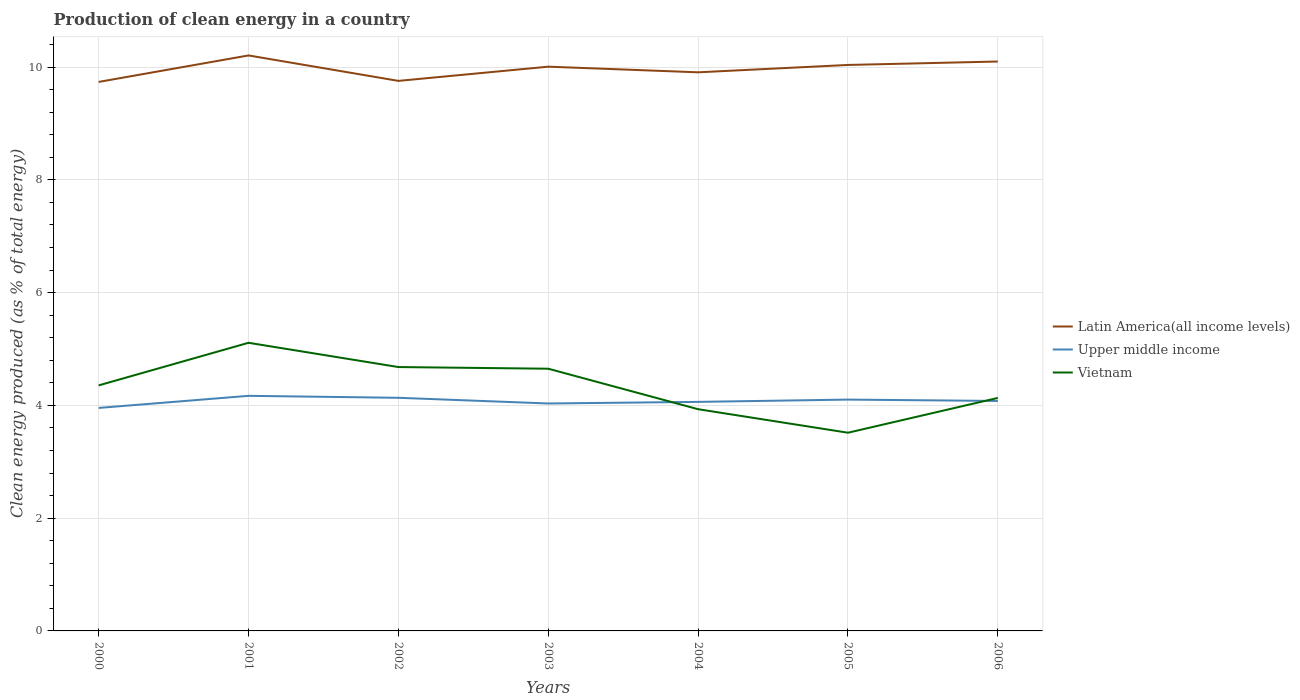How many different coloured lines are there?
Your answer should be very brief. 3. Is the number of lines equal to the number of legend labels?
Provide a short and direct response. Yes. Across all years, what is the maximum percentage of clean energy produced in Upper middle income?
Your answer should be very brief. 3.95. In which year was the percentage of clean energy produced in Upper middle income maximum?
Offer a terse response. 2000. What is the total percentage of clean energy produced in Latin America(all income levels) in the graph?
Your answer should be very brief. 0.11. What is the difference between the highest and the second highest percentage of clean energy produced in Latin America(all income levels)?
Make the answer very short. 0.47. What is the difference between the highest and the lowest percentage of clean energy produced in Upper middle income?
Offer a very short reply. 4. Is the percentage of clean energy produced in Vietnam strictly greater than the percentage of clean energy produced in Latin America(all income levels) over the years?
Your response must be concise. Yes. How many lines are there?
Provide a short and direct response. 3. What is the difference between two consecutive major ticks on the Y-axis?
Provide a short and direct response. 2. Are the values on the major ticks of Y-axis written in scientific E-notation?
Your response must be concise. No. Does the graph contain any zero values?
Provide a short and direct response. No. Does the graph contain grids?
Provide a succinct answer. Yes. Where does the legend appear in the graph?
Your answer should be very brief. Center right. How many legend labels are there?
Make the answer very short. 3. What is the title of the graph?
Ensure brevity in your answer.  Production of clean energy in a country. What is the label or title of the Y-axis?
Provide a short and direct response. Clean energy produced (as % of total energy). What is the Clean energy produced (as % of total energy) in Latin America(all income levels) in 2000?
Your response must be concise. 9.74. What is the Clean energy produced (as % of total energy) of Upper middle income in 2000?
Give a very brief answer. 3.95. What is the Clean energy produced (as % of total energy) of Vietnam in 2000?
Provide a succinct answer. 4.35. What is the Clean energy produced (as % of total energy) of Latin America(all income levels) in 2001?
Your response must be concise. 10.21. What is the Clean energy produced (as % of total energy) in Upper middle income in 2001?
Provide a succinct answer. 4.17. What is the Clean energy produced (as % of total energy) of Vietnam in 2001?
Give a very brief answer. 5.11. What is the Clean energy produced (as % of total energy) in Latin America(all income levels) in 2002?
Your answer should be very brief. 9.76. What is the Clean energy produced (as % of total energy) in Upper middle income in 2002?
Your response must be concise. 4.13. What is the Clean energy produced (as % of total energy) in Vietnam in 2002?
Ensure brevity in your answer.  4.68. What is the Clean energy produced (as % of total energy) of Latin America(all income levels) in 2003?
Keep it short and to the point. 10.01. What is the Clean energy produced (as % of total energy) in Upper middle income in 2003?
Your answer should be very brief. 4.03. What is the Clean energy produced (as % of total energy) in Vietnam in 2003?
Your response must be concise. 4.65. What is the Clean energy produced (as % of total energy) in Latin America(all income levels) in 2004?
Give a very brief answer. 9.91. What is the Clean energy produced (as % of total energy) of Upper middle income in 2004?
Offer a very short reply. 4.06. What is the Clean energy produced (as % of total energy) of Vietnam in 2004?
Ensure brevity in your answer.  3.93. What is the Clean energy produced (as % of total energy) in Latin America(all income levels) in 2005?
Your answer should be very brief. 10.04. What is the Clean energy produced (as % of total energy) in Upper middle income in 2005?
Keep it short and to the point. 4.1. What is the Clean energy produced (as % of total energy) of Vietnam in 2005?
Offer a terse response. 3.52. What is the Clean energy produced (as % of total energy) in Latin America(all income levels) in 2006?
Give a very brief answer. 10.1. What is the Clean energy produced (as % of total energy) of Upper middle income in 2006?
Keep it short and to the point. 4.08. What is the Clean energy produced (as % of total energy) of Vietnam in 2006?
Provide a succinct answer. 4.13. Across all years, what is the maximum Clean energy produced (as % of total energy) in Latin America(all income levels)?
Your answer should be very brief. 10.21. Across all years, what is the maximum Clean energy produced (as % of total energy) in Upper middle income?
Give a very brief answer. 4.17. Across all years, what is the maximum Clean energy produced (as % of total energy) of Vietnam?
Offer a very short reply. 5.11. Across all years, what is the minimum Clean energy produced (as % of total energy) in Latin America(all income levels)?
Ensure brevity in your answer.  9.74. Across all years, what is the minimum Clean energy produced (as % of total energy) of Upper middle income?
Your response must be concise. 3.95. Across all years, what is the minimum Clean energy produced (as % of total energy) of Vietnam?
Give a very brief answer. 3.52. What is the total Clean energy produced (as % of total energy) of Latin America(all income levels) in the graph?
Provide a short and direct response. 69.75. What is the total Clean energy produced (as % of total energy) in Upper middle income in the graph?
Keep it short and to the point. 28.54. What is the total Clean energy produced (as % of total energy) of Vietnam in the graph?
Give a very brief answer. 30.38. What is the difference between the Clean energy produced (as % of total energy) of Latin America(all income levels) in 2000 and that in 2001?
Ensure brevity in your answer.  -0.47. What is the difference between the Clean energy produced (as % of total energy) in Upper middle income in 2000 and that in 2001?
Your answer should be compact. -0.21. What is the difference between the Clean energy produced (as % of total energy) of Vietnam in 2000 and that in 2001?
Ensure brevity in your answer.  -0.76. What is the difference between the Clean energy produced (as % of total energy) of Latin America(all income levels) in 2000 and that in 2002?
Your answer should be very brief. -0.02. What is the difference between the Clean energy produced (as % of total energy) of Upper middle income in 2000 and that in 2002?
Make the answer very short. -0.18. What is the difference between the Clean energy produced (as % of total energy) in Vietnam in 2000 and that in 2002?
Keep it short and to the point. -0.33. What is the difference between the Clean energy produced (as % of total energy) of Latin America(all income levels) in 2000 and that in 2003?
Keep it short and to the point. -0.27. What is the difference between the Clean energy produced (as % of total energy) in Upper middle income in 2000 and that in 2003?
Provide a short and direct response. -0.08. What is the difference between the Clean energy produced (as % of total energy) of Vietnam in 2000 and that in 2003?
Offer a very short reply. -0.3. What is the difference between the Clean energy produced (as % of total energy) of Latin America(all income levels) in 2000 and that in 2004?
Give a very brief answer. -0.17. What is the difference between the Clean energy produced (as % of total energy) of Upper middle income in 2000 and that in 2004?
Make the answer very short. -0.11. What is the difference between the Clean energy produced (as % of total energy) in Vietnam in 2000 and that in 2004?
Provide a succinct answer. 0.42. What is the difference between the Clean energy produced (as % of total energy) in Latin America(all income levels) in 2000 and that in 2005?
Keep it short and to the point. -0.3. What is the difference between the Clean energy produced (as % of total energy) of Upper middle income in 2000 and that in 2005?
Offer a very short reply. -0.15. What is the difference between the Clean energy produced (as % of total energy) of Vietnam in 2000 and that in 2005?
Your answer should be compact. 0.84. What is the difference between the Clean energy produced (as % of total energy) of Latin America(all income levels) in 2000 and that in 2006?
Make the answer very short. -0.36. What is the difference between the Clean energy produced (as % of total energy) of Upper middle income in 2000 and that in 2006?
Ensure brevity in your answer.  -0.12. What is the difference between the Clean energy produced (as % of total energy) of Vietnam in 2000 and that in 2006?
Your answer should be very brief. 0.22. What is the difference between the Clean energy produced (as % of total energy) in Latin America(all income levels) in 2001 and that in 2002?
Your answer should be very brief. 0.45. What is the difference between the Clean energy produced (as % of total energy) in Upper middle income in 2001 and that in 2002?
Give a very brief answer. 0.03. What is the difference between the Clean energy produced (as % of total energy) of Vietnam in 2001 and that in 2002?
Your response must be concise. 0.43. What is the difference between the Clean energy produced (as % of total energy) in Latin America(all income levels) in 2001 and that in 2003?
Ensure brevity in your answer.  0.2. What is the difference between the Clean energy produced (as % of total energy) in Upper middle income in 2001 and that in 2003?
Give a very brief answer. 0.14. What is the difference between the Clean energy produced (as % of total energy) in Vietnam in 2001 and that in 2003?
Your response must be concise. 0.46. What is the difference between the Clean energy produced (as % of total energy) in Latin America(all income levels) in 2001 and that in 2004?
Make the answer very short. 0.3. What is the difference between the Clean energy produced (as % of total energy) in Upper middle income in 2001 and that in 2004?
Make the answer very short. 0.11. What is the difference between the Clean energy produced (as % of total energy) of Vietnam in 2001 and that in 2004?
Provide a short and direct response. 1.18. What is the difference between the Clean energy produced (as % of total energy) in Latin America(all income levels) in 2001 and that in 2005?
Offer a very short reply. 0.17. What is the difference between the Clean energy produced (as % of total energy) of Upper middle income in 2001 and that in 2005?
Ensure brevity in your answer.  0.07. What is the difference between the Clean energy produced (as % of total energy) in Vietnam in 2001 and that in 2005?
Keep it short and to the point. 1.59. What is the difference between the Clean energy produced (as % of total energy) in Latin America(all income levels) in 2001 and that in 2006?
Your answer should be compact. 0.11. What is the difference between the Clean energy produced (as % of total energy) of Upper middle income in 2001 and that in 2006?
Give a very brief answer. 0.09. What is the difference between the Clean energy produced (as % of total energy) in Vietnam in 2001 and that in 2006?
Offer a terse response. 0.98. What is the difference between the Clean energy produced (as % of total energy) of Latin America(all income levels) in 2002 and that in 2003?
Offer a terse response. -0.25. What is the difference between the Clean energy produced (as % of total energy) in Upper middle income in 2002 and that in 2003?
Ensure brevity in your answer.  0.1. What is the difference between the Clean energy produced (as % of total energy) of Vietnam in 2002 and that in 2003?
Provide a succinct answer. 0.03. What is the difference between the Clean energy produced (as % of total energy) of Latin America(all income levels) in 2002 and that in 2004?
Your answer should be very brief. -0.15. What is the difference between the Clean energy produced (as % of total energy) in Upper middle income in 2002 and that in 2004?
Offer a very short reply. 0.07. What is the difference between the Clean energy produced (as % of total energy) of Vietnam in 2002 and that in 2004?
Ensure brevity in your answer.  0.75. What is the difference between the Clean energy produced (as % of total energy) in Latin America(all income levels) in 2002 and that in 2005?
Keep it short and to the point. -0.28. What is the difference between the Clean energy produced (as % of total energy) of Upper middle income in 2002 and that in 2005?
Make the answer very short. 0.03. What is the difference between the Clean energy produced (as % of total energy) in Vietnam in 2002 and that in 2005?
Make the answer very short. 1.16. What is the difference between the Clean energy produced (as % of total energy) of Latin America(all income levels) in 2002 and that in 2006?
Your answer should be very brief. -0.34. What is the difference between the Clean energy produced (as % of total energy) in Upper middle income in 2002 and that in 2006?
Offer a terse response. 0.06. What is the difference between the Clean energy produced (as % of total energy) of Vietnam in 2002 and that in 2006?
Your answer should be very brief. 0.55. What is the difference between the Clean energy produced (as % of total energy) in Latin America(all income levels) in 2003 and that in 2004?
Make the answer very short. 0.1. What is the difference between the Clean energy produced (as % of total energy) of Upper middle income in 2003 and that in 2004?
Ensure brevity in your answer.  -0.03. What is the difference between the Clean energy produced (as % of total energy) of Vietnam in 2003 and that in 2004?
Your answer should be very brief. 0.72. What is the difference between the Clean energy produced (as % of total energy) in Latin America(all income levels) in 2003 and that in 2005?
Keep it short and to the point. -0.03. What is the difference between the Clean energy produced (as % of total energy) of Upper middle income in 2003 and that in 2005?
Provide a short and direct response. -0.07. What is the difference between the Clean energy produced (as % of total energy) of Vietnam in 2003 and that in 2005?
Provide a succinct answer. 1.14. What is the difference between the Clean energy produced (as % of total energy) of Latin America(all income levels) in 2003 and that in 2006?
Keep it short and to the point. -0.09. What is the difference between the Clean energy produced (as % of total energy) of Upper middle income in 2003 and that in 2006?
Make the answer very short. -0.04. What is the difference between the Clean energy produced (as % of total energy) in Vietnam in 2003 and that in 2006?
Make the answer very short. 0.52. What is the difference between the Clean energy produced (as % of total energy) of Latin America(all income levels) in 2004 and that in 2005?
Your answer should be very brief. -0.13. What is the difference between the Clean energy produced (as % of total energy) of Upper middle income in 2004 and that in 2005?
Provide a short and direct response. -0.04. What is the difference between the Clean energy produced (as % of total energy) of Vietnam in 2004 and that in 2005?
Your answer should be compact. 0.42. What is the difference between the Clean energy produced (as % of total energy) in Latin America(all income levels) in 2004 and that in 2006?
Ensure brevity in your answer.  -0.19. What is the difference between the Clean energy produced (as % of total energy) of Upper middle income in 2004 and that in 2006?
Make the answer very short. -0.02. What is the difference between the Clean energy produced (as % of total energy) of Vietnam in 2004 and that in 2006?
Make the answer very short. -0.2. What is the difference between the Clean energy produced (as % of total energy) of Latin America(all income levels) in 2005 and that in 2006?
Offer a very short reply. -0.06. What is the difference between the Clean energy produced (as % of total energy) of Upper middle income in 2005 and that in 2006?
Make the answer very short. 0.02. What is the difference between the Clean energy produced (as % of total energy) of Vietnam in 2005 and that in 2006?
Keep it short and to the point. -0.62. What is the difference between the Clean energy produced (as % of total energy) in Latin America(all income levels) in 2000 and the Clean energy produced (as % of total energy) in Upper middle income in 2001?
Your answer should be compact. 5.57. What is the difference between the Clean energy produced (as % of total energy) of Latin America(all income levels) in 2000 and the Clean energy produced (as % of total energy) of Vietnam in 2001?
Provide a short and direct response. 4.63. What is the difference between the Clean energy produced (as % of total energy) of Upper middle income in 2000 and the Clean energy produced (as % of total energy) of Vietnam in 2001?
Offer a terse response. -1.16. What is the difference between the Clean energy produced (as % of total energy) in Latin America(all income levels) in 2000 and the Clean energy produced (as % of total energy) in Upper middle income in 2002?
Make the answer very short. 5.6. What is the difference between the Clean energy produced (as % of total energy) in Latin America(all income levels) in 2000 and the Clean energy produced (as % of total energy) in Vietnam in 2002?
Ensure brevity in your answer.  5.06. What is the difference between the Clean energy produced (as % of total energy) in Upper middle income in 2000 and the Clean energy produced (as % of total energy) in Vietnam in 2002?
Your response must be concise. -0.72. What is the difference between the Clean energy produced (as % of total energy) of Latin America(all income levels) in 2000 and the Clean energy produced (as % of total energy) of Upper middle income in 2003?
Offer a terse response. 5.7. What is the difference between the Clean energy produced (as % of total energy) in Latin America(all income levels) in 2000 and the Clean energy produced (as % of total energy) in Vietnam in 2003?
Offer a terse response. 5.09. What is the difference between the Clean energy produced (as % of total energy) of Upper middle income in 2000 and the Clean energy produced (as % of total energy) of Vietnam in 2003?
Give a very brief answer. -0.7. What is the difference between the Clean energy produced (as % of total energy) of Latin America(all income levels) in 2000 and the Clean energy produced (as % of total energy) of Upper middle income in 2004?
Your answer should be compact. 5.67. What is the difference between the Clean energy produced (as % of total energy) of Latin America(all income levels) in 2000 and the Clean energy produced (as % of total energy) of Vietnam in 2004?
Keep it short and to the point. 5.8. What is the difference between the Clean energy produced (as % of total energy) in Upper middle income in 2000 and the Clean energy produced (as % of total energy) in Vietnam in 2004?
Keep it short and to the point. 0.02. What is the difference between the Clean energy produced (as % of total energy) of Latin America(all income levels) in 2000 and the Clean energy produced (as % of total energy) of Upper middle income in 2005?
Keep it short and to the point. 5.63. What is the difference between the Clean energy produced (as % of total energy) of Latin America(all income levels) in 2000 and the Clean energy produced (as % of total energy) of Vietnam in 2005?
Offer a very short reply. 6.22. What is the difference between the Clean energy produced (as % of total energy) of Upper middle income in 2000 and the Clean energy produced (as % of total energy) of Vietnam in 2005?
Your response must be concise. 0.44. What is the difference between the Clean energy produced (as % of total energy) in Latin America(all income levels) in 2000 and the Clean energy produced (as % of total energy) in Upper middle income in 2006?
Your response must be concise. 5.66. What is the difference between the Clean energy produced (as % of total energy) of Latin America(all income levels) in 2000 and the Clean energy produced (as % of total energy) of Vietnam in 2006?
Give a very brief answer. 5.6. What is the difference between the Clean energy produced (as % of total energy) of Upper middle income in 2000 and the Clean energy produced (as % of total energy) of Vietnam in 2006?
Your response must be concise. -0.18. What is the difference between the Clean energy produced (as % of total energy) in Latin America(all income levels) in 2001 and the Clean energy produced (as % of total energy) in Upper middle income in 2002?
Your response must be concise. 6.07. What is the difference between the Clean energy produced (as % of total energy) in Latin America(all income levels) in 2001 and the Clean energy produced (as % of total energy) in Vietnam in 2002?
Make the answer very short. 5.53. What is the difference between the Clean energy produced (as % of total energy) in Upper middle income in 2001 and the Clean energy produced (as % of total energy) in Vietnam in 2002?
Your response must be concise. -0.51. What is the difference between the Clean energy produced (as % of total energy) in Latin America(all income levels) in 2001 and the Clean energy produced (as % of total energy) in Upper middle income in 2003?
Provide a short and direct response. 6.17. What is the difference between the Clean energy produced (as % of total energy) in Latin America(all income levels) in 2001 and the Clean energy produced (as % of total energy) in Vietnam in 2003?
Offer a very short reply. 5.56. What is the difference between the Clean energy produced (as % of total energy) in Upper middle income in 2001 and the Clean energy produced (as % of total energy) in Vietnam in 2003?
Provide a succinct answer. -0.48. What is the difference between the Clean energy produced (as % of total energy) in Latin America(all income levels) in 2001 and the Clean energy produced (as % of total energy) in Upper middle income in 2004?
Ensure brevity in your answer.  6.14. What is the difference between the Clean energy produced (as % of total energy) of Latin America(all income levels) in 2001 and the Clean energy produced (as % of total energy) of Vietnam in 2004?
Your answer should be compact. 6.27. What is the difference between the Clean energy produced (as % of total energy) of Upper middle income in 2001 and the Clean energy produced (as % of total energy) of Vietnam in 2004?
Provide a short and direct response. 0.24. What is the difference between the Clean energy produced (as % of total energy) in Latin America(all income levels) in 2001 and the Clean energy produced (as % of total energy) in Upper middle income in 2005?
Provide a succinct answer. 6.1. What is the difference between the Clean energy produced (as % of total energy) in Latin America(all income levels) in 2001 and the Clean energy produced (as % of total energy) in Vietnam in 2005?
Your answer should be compact. 6.69. What is the difference between the Clean energy produced (as % of total energy) in Upper middle income in 2001 and the Clean energy produced (as % of total energy) in Vietnam in 2005?
Ensure brevity in your answer.  0.65. What is the difference between the Clean energy produced (as % of total energy) in Latin America(all income levels) in 2001 and the Clean energy produced (as % of total energy) in Upper middle income in 2006?
Your answer should be compact. 6.13. What is the difference between the Clean energy produced (as % of total energy) in Latin America(all income levels) in 2001 and the Clean energy produced (as % of total energy) in Vietnam in 2006?
Your answer should be compact. 6.07. What is the difference between the Clean energy produced (as % of total energy) of Upper middle income in 2001 and the Clean energy produced (as % of total energy) of Vietnam in 2006?
Give a very brief answer. 0.04. What is the difference between the Clean energy produced (as % of total energy) of Latin America(all income levels) in 2002 and the Clean energy produced (as % of total energy) of Upper middle income in 2003?
Provide a short and direct response. 5.72. What is the difference between the Clean energy produced (as % of total energy) of Latin America(all income levels) in 2002 and the Clean energy produced (as % of total energy) of Vietnam in 2003?
Ensure brevity in your answer.  5.1. What is the difference between the Clean energy produced (as % of total energy) in Upper middle income in 2002 and the Clean energy produced (as % of total energy) in Vietnam in 2003?
Your answer should be compact. -0.52. What is the difference between the Clean energy produced (as % of total energy) of Latin America(all income levels) in 2002 and the Clean energy produced (as % of total energy) of Upper middle income in 2004?
Provide a succinct answer. 5.69. What is the difference between the Clean energy produced (as % of total energy) in Latin America(all income levels) in 2002 and the Clean energy produced (as % of total energy) in Vietnam in 2004?
Offer a terse response. 5.82. What is the difference between the Clean energy produced (as % of total energy) in Upper middle income in 2002 and the Clean energy produced (as % of total energy) in Vietnam in 2004?
Your answer should be very brief. 0.2. What is the difference between the Clean energy produced (as % of total energy) of Latin America(all income levels) in 2002 and the Clean energy produced (as % of total energy) of Upper middle income in 2005?
Keep it short and to the point. 5.65. What is the difference between the Clean energy produced (as % of total energy) of Latin America(all income levels) in 2002 and the Clean energy produced (as % of total energy) of Vietnam in 2005?
Make the answer very short. 6.24. What is the difference between the Clean energy produced (as % of total energy) in Upper middle income in 2002 and the Clean energy produced (as % of total energy) in Vietnam in 2005?
Keep it short and to the point. 0.62. What is the difference between the Clean energy produced (as % of total energy) in Latin America(all income levels) in 2002 and the Clean energy produced (as % of total energy) in Upper middle income in 2006?
Give a very brief answer. 5.68. What is the difference between the Clean energy produced (as % of total energy) of Latin America(all income levels) in 2002 and the Clean energy produced (as % of total energy) of Vietnam in 2006?
Offer a very short reply. 5.62. What is the difference between the Clean energy produced (as % of total energy) in Upper middle income in 2002 and the Clean energy produced (as % of total energy) in Vietnam in 2006?
Your response must be concise. 0. What is the difference between the Clean energy produced (as % of total energy) in Latin America(all income levels) in 2003 and the Clean energy produced (as % of total energy) in Upper middle income in 2004?
Offer a terse response. 5.95. What is the difference between the Clean energy produced (as % of total energy) of Latin America(all income levels) in 2003 and the Clean energy produced (as % of total energy) of Vietnam in 2004?
Your answer should be compact. 6.07. What is the difference between the Clean energy produced (as % of total energy) of Upper middle income in 2003 and the Clean energy produced (as % of total energy) of Vietnam in 2004?
Keep it short and to the point. 0.1. What is the difference between the Clean energy produced (as % of total energy) in Latin America(all income levels) in 2003 and the Clean energy produced (as % of total energy) in Upper middle income in 2005?
Ensure brevity in your answer.  5.9. What is the difference between the Clean energy produced (as % of total energy) in Latin America(all income levels) in 2003 and the Clean energy produced (as % of total energy) in Vietnam in 2005?
Ensure brevity in your answer.  6.49. What is the difference between the Clean energy produced (as % of total energy) in Upper middle income in 2003 and the Clean energy produced (as % of total energy) in Vietnam in 2005?
Keep it short and to the point. 0.52. What is the difference between the Clean energy produced (as % of total energy) of Latin America(all income levels) in 2003 and the Clean energy produced (as % of total energy) of Upper middle income in 2006?
Your response must be concise. 5.93. What is the difference between the Clean energy produced (as % of total energy) of Latin America(all income levels) in 2003 and the Clean energy produced (as % of total energy) of Vietnam in 2006?
Your answer should be very brief. 5.88. What is the difference between the Clean energy produced (as % of total energy) in Upper middle income in 2003 and the Clean energy produced (as % of total energy) in Vietnam in 2006?
Offer a very short reply. -0.1. What is the difference between the Clean energy produced (as % of total energy) in Latin America(all income levels) in 2004 and the Clean energy produced (as % of total energy) in Upper middle income in 2005?
Offer a terse response. 5.8. What is the difference between the Clean energy produced (as % of total energy) in Latin America(all income levels) in 2004 and the Clean energy produced (as % of total energy) in Vietnam in 2005?
Ensure brevity in your answer.  6.39. What is the difference between the Clean energy produced (as % of total energy) of Upper middle income in 2004 and the Clean energy produced (as % of total energy) of Vietnam in 2005?
Your response must be concise. 0.55. What is the difference between the Clean energy produced (as % of total energy) in Latin America(all income levels) in 2004 and the Clean energy produced (as % of total energy) in Upper middle income in 2006?
Make the answer very short. 5.83. What is the difference between the Clean energy produced (as % of total energy) of Latin America(all income levels) in 2004 and the Clean energy produced (as % of total energy) of Vietnam in 2006?
Make the answer very short. 5.78. What is the difference between the Clean energy produced (as % of total energy) of Upper middle income in 2004 and the Clean energy produced (as % of total energy) of Vietnam in 2006?
Give a very brief answer. -0.07. What is the difference between the Clean energy produced (as % of total energy) in Latin America(all income levels) in 2005 and the Clean energy produced (as % of total energy) in Upper middle income in 2006?
Ensure brevity in your answer.  5.96. What is the difference between the Clean energy produced (as % of total energy) of Latin America(all income levels) in 2005 and the Clean energy produced (as % of total energy) of Vietnam in 2006?
Give a very brief answer. 5.91. What is the difference between the Clean energy produced (as % of total energy) of Upper middle income in 2005 and the Clean energy produced (as % of total energy) of Vietnam in 2006?
Give a very brief answer. -0.03. What is the average Clean energy produced (as % of total energy) in Latin America(all income levels) per year?
Offer a terse response. 9.96. What is the average Clean energy produced (as % of total energy) of Upper middle income per year?
Provide a succinct answer. 4.08. What is the average Clean energy produced (as % of total energy) in Vietnam per year?
Your answer should be very brief. 4.34. In the year 2000, what is the difference between the Clean energy produced (as % of total energy) of Latin America(all income levels) and Clean energy produced (as % of total energy) of Upper middle income?
Offer a terse response. 5.78. In the year 2000, what is the difference between the Clean energy produced (as % of total energy) in Latin America(all income levels) and Clean energy produced (as % of total energy) in Vietnam?
Provide a short and direct response. 5.38. In the year 2000, what is the difference between the Clean energy produced (as % of total energy) of Upper middle income and Clean energy produced (as % of total energy) of Vietnam?
Your answer should be very brief. -0.4. In the year 2001, what is the difference between the Clean energy produced (as % of total energy) in Latin America(all income levels) and Clean energy produced (as % of total energy) in Upper middle income?
Your answer should be very brief. 6.04. In the year 2001, what is the difference between the Clean energy produced (as % of total energy) in Latin America(all income levels) and Clean energy produced (as % of total energy) in Vietnam?
Your answer should be compact. 5.1. In the year 2001, what is the difference between the Clean energy produced (as % of total energy) in Upper middle income and Clean energy produced (as % of total energy) in Vietnam?
Your answer should be very brief. -0.94. In the year 2002, what is the difference between the Clean energy produced (as % of total energy) of Latin America(all income levels) and Clean energy produced (as % of total energy) of Upper middle income?
Provide a succinct answer. 5.62. In the year 2002, what is the difference between the Clean energy produced (as % of total energy) of Latin America(all income levels) and Clean energy produced (as % of total energy) of Vietnam?
Offer a terse response. 5.08. In the year 2002, what is the difference between the Clean energy produced (as % of total energy) of Upper middle income and Clean energy produced (as % of total energy) of Vietnam?
Provide a short and direct response. -0.55. In the year 2003, what is the difference between the Clean energy produced (as % of total energy) of Latin America(all income levels) and Clean energy produced (as % of total energy) of Upper middle income?
Provide a short and direct response. 5.97. In the year 2003, what is the difference between the Clean energy produced (as % of total energy) of Latin America(all income levels) and Clean energy produced (as % of total energy) of Vietnam?
Your answer should be very brief. 5.36. In the year 2003, what is the difference between the Clean energy produced (as % of total energy) of Upper middle income and Clean energy produced (as % of total energy) of Vietnam?
Your answer should be compact. -0.62. In the year 2004, what is the difference between the Clean energy produced (as % of total energy) in Latin America(all income levels) and Clean energy produced (as % of total energy) in Upper middle income?
Your answer should be very brief. 5.84. In the year 2004, what is the difference between the Clean energy produced (as % of total energy) in Latin America(all income levels) and Clean energy produced (as % of total energy) in Vietnam?
Keep it short and to the point. 5.97. In the year 2004, what is the difference between the Clean energy produced (as % of total energy) of Upper middle income and Clean energy produced (as % of total energy) of Vietnam?
Your answer should be compact. 0.13. In the year 2005, what is the difference between the Clean energy produced (as % of total energy) in Latin America(all income levels) and Clean energy produced (as % of total energy) in Upper middle income?
Your answer should be very brief. 5.94. In the year 2005, what is the difference between the Clean energy produced (as % of total energy) of Latin America(all income levels) and Clean energy produced (as % of total energy) of Vietnam?
Give a very brief answer. 6.52. In the year 2005, what is the difference between the Clean energy produced (as % of total energy) in Upper middle income and Clean energy produced (as % of total energy) in Vietnam?
Keep it short and to the point. 0.59. In the year 2006, what is the difference between the Clean energy produced (as % of total energy) in Latin America(all income levels) and Clean energy produced (as % of total energy) in Upper middle income?
Your response must be concise. 6.02. In the year 2006, what is the difference between the Clean energy produced (as % of total energy) in Latin America(all income levels) and Clean energy produced (as % of total energy) in Vietnam?
Provide a succinct answer. 5.97. In the year 2006, what is the difference between the Clean energy produced (as % of total energy) of Upper middle income and Clean energy produced (as % of total energy) of Vietnam?
Offer a very short reply. -0.05. What is the ratio of the Clean energy produced (as % of total energy) in Latin America(all income levels) in 2000 to that in 2001?
Provide a short and direct response. 0.95. What is the ratio of the Clean energy produced (as % of total energy) of Upper middle income in 2000 to that in 2001?
Provide a succinct answer. 0.95. What is the ratio of the Clean energy produced (as % of total energy) of Vietnam in 2000 to that in 2001?
Offer a terse response. 0.85. What is the ratio of the Clean energy produced (as % of total energy) in Upper middle income in 2000 to that in 2002?
Your response must be concise. 0.96. What is the ratio of the Clean energy produced (as % of total energy) in Vietnam in 2000 to that in 2002?
Provide a succinct answer. 0.93. What is the ratio of the Clean energy produced (as % of total energy) of Latin America(all income levels) in 2000 to that in 2003?
Offer a very short reply. 0.97. What is the ratio of the Clean energy produced (as % of total energy) of Upper middle income in 2000 to that in 2003?
Provide a short and direct response. 0.98. What is the ratio of the Clean energy produced (as % of total energy) of Vietnam in 2000 to that in 2003?
Provide a succinct answer. 0.94. What is the ratio of the Clean energy produced (as % of total energy) of Latin America(all income levels) in 2000 to that in 2004?
Offer a terse response. 0.98. What is the ratio of the Clean energy produced (as % of total energy) in Upper middle income in 2000 to that in 2004?
Provide a succinct answer. 0.97. What is the ratio of the Clean energy produced (as % of total energy) of Vietnam in 2000 to that in 2004?
Your response must be concise. 1.11. What is the ratio of the Clean energy produced (as % of total energy) in Latin America(all income levels) in 2000 to that in 2005?
Your answer should be compact. 0.97. What is the ratio of the Clean energy produced (as % of total energy) in Vietnam in 2000 to that in 2005?
Offer a very short reply. 1.24. What is the ratio of the Clean energy produced (as % of total energy) of Latin America(all income levels) in 2000 to that in 2006?
Offer a terse response. 0.96. What is the ratio of the Clean energy produced (as % of total energy) of Upper middle income in 2000 to that in 2006?
Your answer should be compact. 0.97. What is the ratio of the Clean energy produced (as % of total energy) in Vietnam in 2000 to that in 2006?
Your answer should be compact. 1.05. What is the ratio of the Clean energy produced (as % of total energy) in Latin America(all income levels) in 2001 to that in 2002?
Ensure brevity in your answer.  1.05. What is the ratio of the Clean energy produced (as % of total energy) in Upper middle income in 2001 to that in 2002?
Keep it short and to the point. 1.01. What is the ratio of the Clean energy produced (as % of total energy) in Vietnam in 2001 to that in 2002?
Your answer should be compact. 1.09. What is the ratio of the Clean energy produced (as % of total energy) in Latin America(all income levels) in 2001 to that in 2003?
Ensure brevity in your answer.  1.02. What is the ratio of the Clean energy produced (as % of total energy) of Upper middle income in 2001 to that in 2003?
Give a very brief answer. 1.03. What is the ratio of the Clean energy produced (as % of total energy) in Vietnam in 2001 to that in 2003?
Make the answer very short. 1.1. What is the ratio of the Clean energy produced (as % of total energy) in Latin America(all income levels) in 2001 to that in 2004?
Provide a short and direct response. 1.03. What is the ratio of the Clean energy produced (as % of total energy) of Upper middle income in 2001 to that in 2004?
Provide a succinct answer. 1.03. What is the ratio of the Clean energy produced (as % of total energy) in Vietnam in 2001 to that in 2004?
Keep it short and to the point. 1.3. What is the ratio of the Clean energy produced (as % of total energy) of Latin America(all income levels) in 2001 to that in 2005?
Keep it short and to the point. 1.02. What is the ratio of the Clean energy produced (as % of total energy) in Upper middle income in 2001 to that in 2005?
Provide a short and direct response. 1.02. What is the ratio of the Clean energy produced (as % of total energy) in Vietnam in 2001 to that in 2005?
Your answer should be very brief. 1.45. What is the ratio of the Clean energy produced (as % of total energy) of Latin America(all income levels) in 2001 to that in 2006?
Keep it short and to the point. 1.01. What is the ratio of the Clean energy produced (as % of total energy) in Upper middle income in 2001 to that in 2006?
Offer a terse response. 1.02. What is the ratio of the Clean energy produced (as % of total energy) in Vietnam in 2001 to that in 2006?
Your answer should be compact. 1.24. What is the ratio of the Clean energy produced (as % of total energy) in Latin America(all income levels) in 2002 to that in 2003?
Your answer should be very brief. 0.97. What is the ratio of the Clean energy produced (as % of total energy) of Latin America(all income levels) in 2002 to that in 2004?
Your answer should be compact. 0.98. What is the ratio of the Clean energy produced (as % of total energy) of Upper middle income in 2002 to that in 2004?
Give a very brief answer. 1.02. What is the ratio of the Clean energy produced (as % of total energy) of Vietnam in 2002 to that in 2004?
Keep it short and to the point. 1.19. What is the ratio of the Clean energy produced (as % of total energy) of Latin America(all income levels) in 2002 to that in 2005?
Your answer should be very brief. 0.97. What is the ratio of the Clean energy produced (as % of total energy) in Upper middle income in 2002 to that in 2005?
Give a very brief answer. 1.01. What is the ratio of the Clean energy produced (as % of total energy) in Vietnam in 2002 to that in 2005?
Provide a short and direct response. 1.33. What is the ratio of the Clean energy produced (as % of total energy) in Upper middle income in 2002 to that in 2006?
Offer a terse response. 1.01. What is the ratio of the Clean energy produced (as % of total energy) of Vietnam in 2002 to that in 2006?
Ensure brevity in your answer.  1.13. What is the ratio of the Clean energy produced (as % of total energy) in Vietnam in 2003 to that in 2004?
Offer a terse response. 1.18. What is the ratio of the Clean energy produced (as % of total energy) in Latin America(all income levels) in 2003 to that in 2005?
Your response must be concise. 1. What is the ratio of the Clean energy produced (as % of total energy) of Upper middle income in 2003 to that in 2005?
Keep it short and to the point. 0.98. What is the ratio of the Clean energy produced (as % of total energy) in Vietnam in 2003 to that in 2005?
Your answer should be very brief. 1.32. What is the ratio of the Clean energy produced (as % of total energy) in Latin America(all income levels) in 2003 to that in 2006?
Provide a short and direct response. 0.99. What is the ratio of the Clean energy produced (as % of total energy) in Vietnam in 2003 to that in 2006?
Keep it short and to the point. 1.13. What is the ratio of the Clean energy produced (as % of total energy) of Latin America(all income levels) in 2004 to that in 2005?
Provide a succinct answer. 0.99. What is the ratio of the Clean energy produced (as % of total energy) of Upper middle income in 2004 to that in 2005?
Make the answer very short. 0.99. What is the ratio of the Clean energy produced (as % of total energy) in Vietnam in 2004 to that in 2005?
Your answer should be compact. 1.12. What is the ratio of the Clean energy produced (as % of total energy) in Latin America(all income levels) in 2004 to that in 2006?
Keep it short and to the point. 0.98. What is the ratio of the Clean energy produced (as % of total energy) of Vietnam in 2004 to that in 2006?
Your answer should be very brief. 0.95. What is the ratio of the Clean energy produced (as % of total energy) in Upper middle income in 2005 to that in 2006?
Your answer should be compact. 1.01. What is the ratio of the Clean energy produced (as % of total energy) of Vietnam in 2005 to that in 2006?
Keep it short and to the point. 0.85. What is the difference between the highest and the second highest Clean energy produced (as % of total energy) in Latin America(all income levels)?
Offer a very short reply. 0.11. What is the difference between the highest and the second highest Clean energy produced (as % of total energy) of Upper middle income?
Offer a very short reply. 0.03. What is the difference between the highest and the second highest Clean energy produced (as % of total energy) of Vietnam?
Offer a terse response. 0.43. What is the difference between the highest and the lowest Clean energy produced (as % of total energy) of Latin America(all income levels)?
Give a very brief answer. 0.47. What is the difference between the highest and the lowest Clean energy produced (as % of total energy) of Upper middle income?
Provide a succinct answer. 0.21. What is the difference between the highest and the lowest Clean energy produced (as % of total energy) of Vietnam?
Offer a terse response. 1.59. 